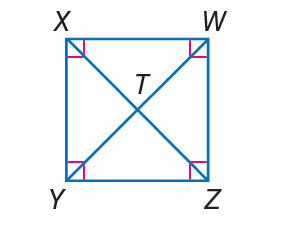Answer the mathemtical geometry problem and directly provide the correct option letter.
Question: W X Y Z is a square. If W T = 3. Find X Y.
Choices: A: 3 B: 3 \sqrt { 2 } C: 6 D: 10 B 